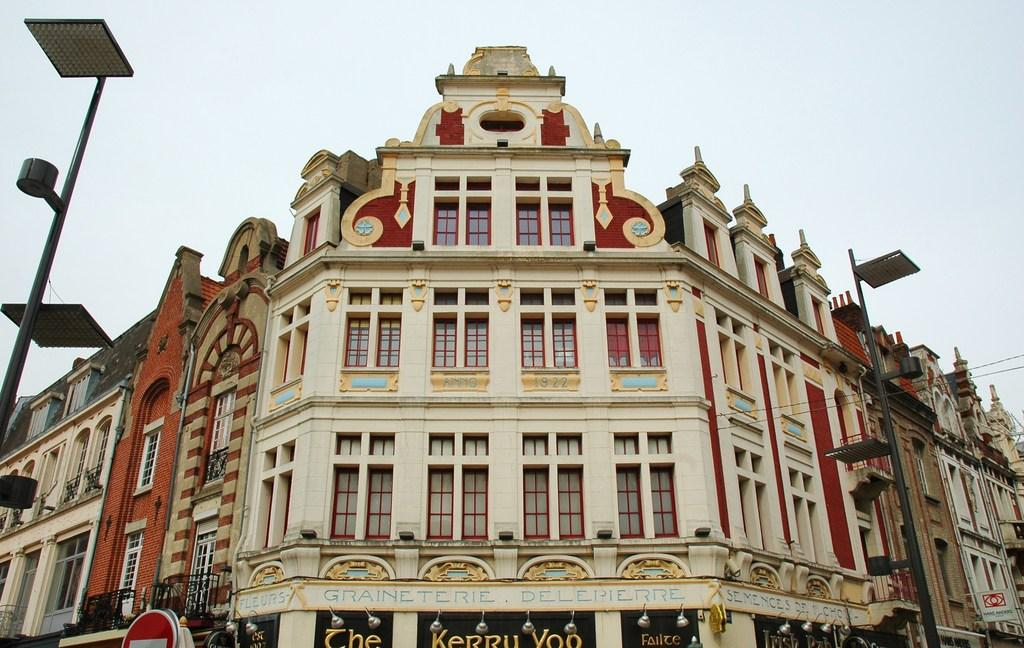What type of structure is present in the image? There is a building in the image. What objects can be seen near the building? There are boards, lights, and poles in the image. What can be seen in the background of the image? The sky is visible in the background of the image. Are there any boats visible on the map in the image? There is no map or boats present in the image. What type of record is being played on the record player in the image? There is no record player or record present in the image. 